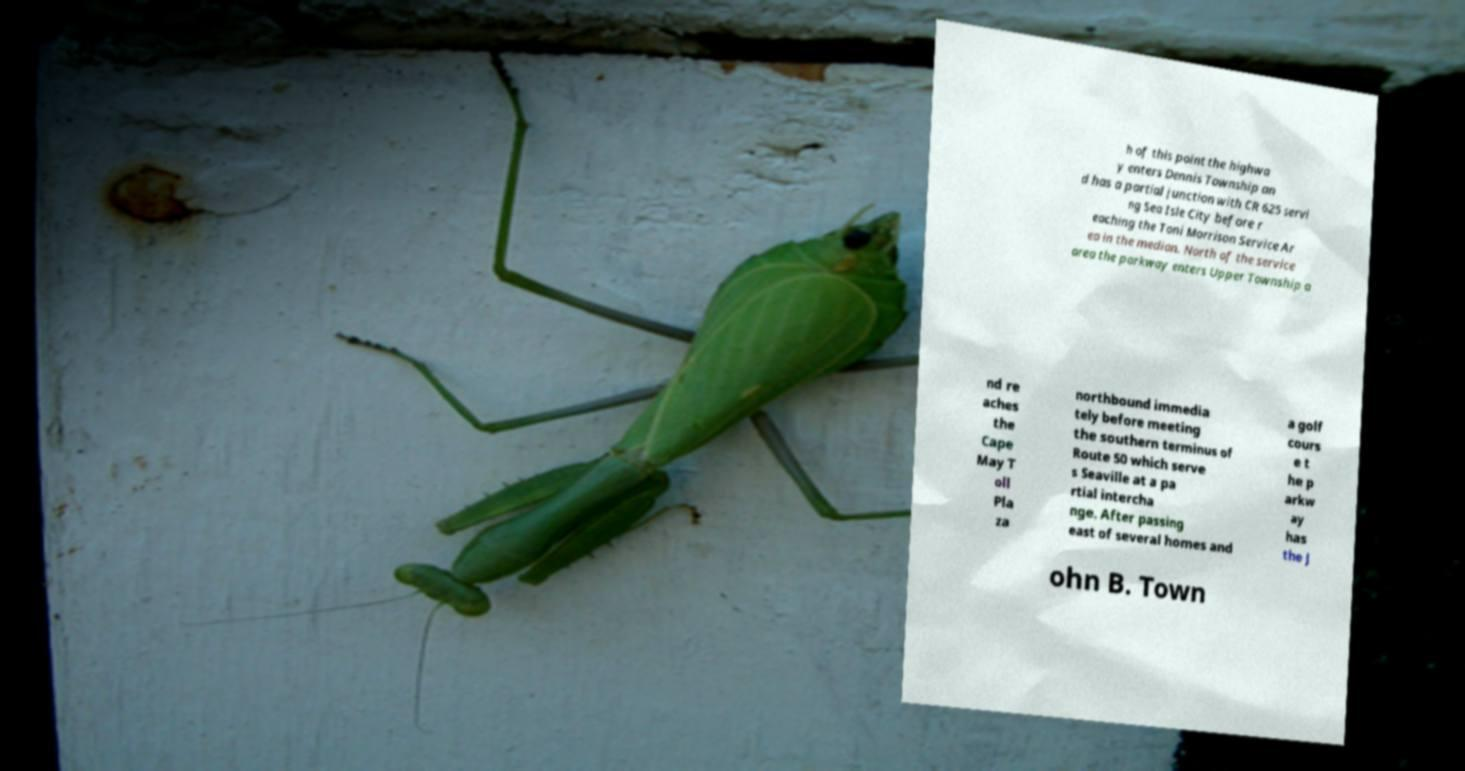I need the written content from this picture converted into text. Can you do that? h of this point the highwa y enters Dennis Township an d has a partial junction with CR 625 servi ng Sea Isle City before r eaching the Toni Morrison Service Ar ea in the median. North of the service area the parkway enters Upper Township a nd re aches the Cape May T oll Pla za northbound immedia tely before meeting the southern terminus of Route 50 which serve s Seaville at a pa rtial intercha nge. After passing east of several homes and a golf cours e t he p arkw ay has the J ohn B. Town 